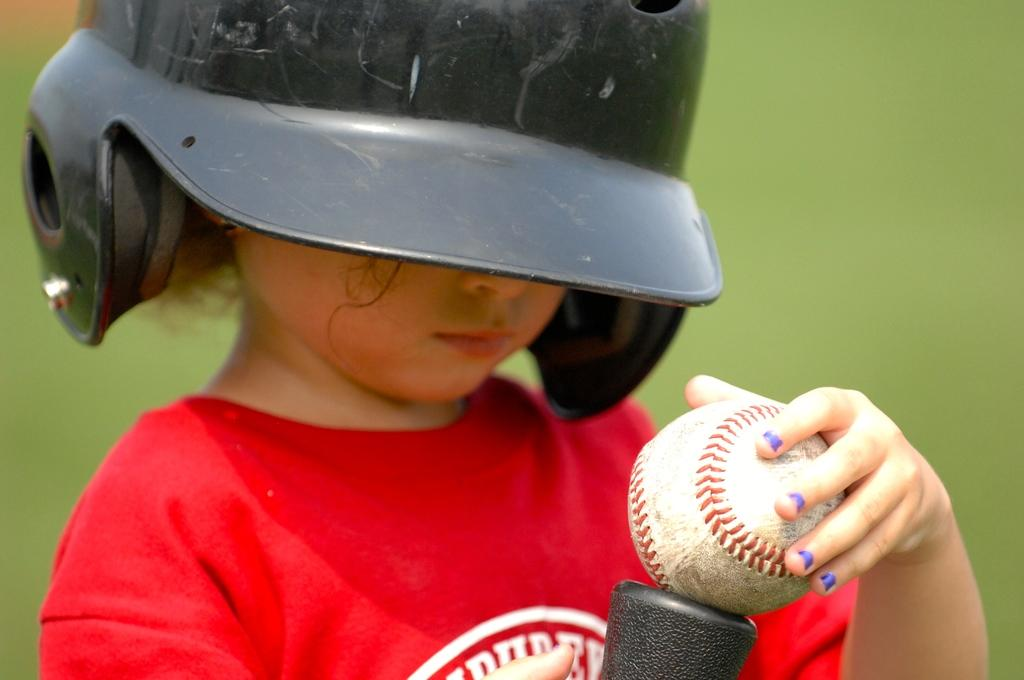What is the main subject of the image? The main subject of the image is a kid. What is the kid wearing on their head? The kid is wearing a helmet on their head. What object is the kid holding in their hand? The kid is holding a baseball ball in their hand. Can you describe the background of the image? The background of the image is blurry. What type of chair is the kid sitting on in the image? There is no chair present in the image; the kid is standing and holding a baseball ball. 